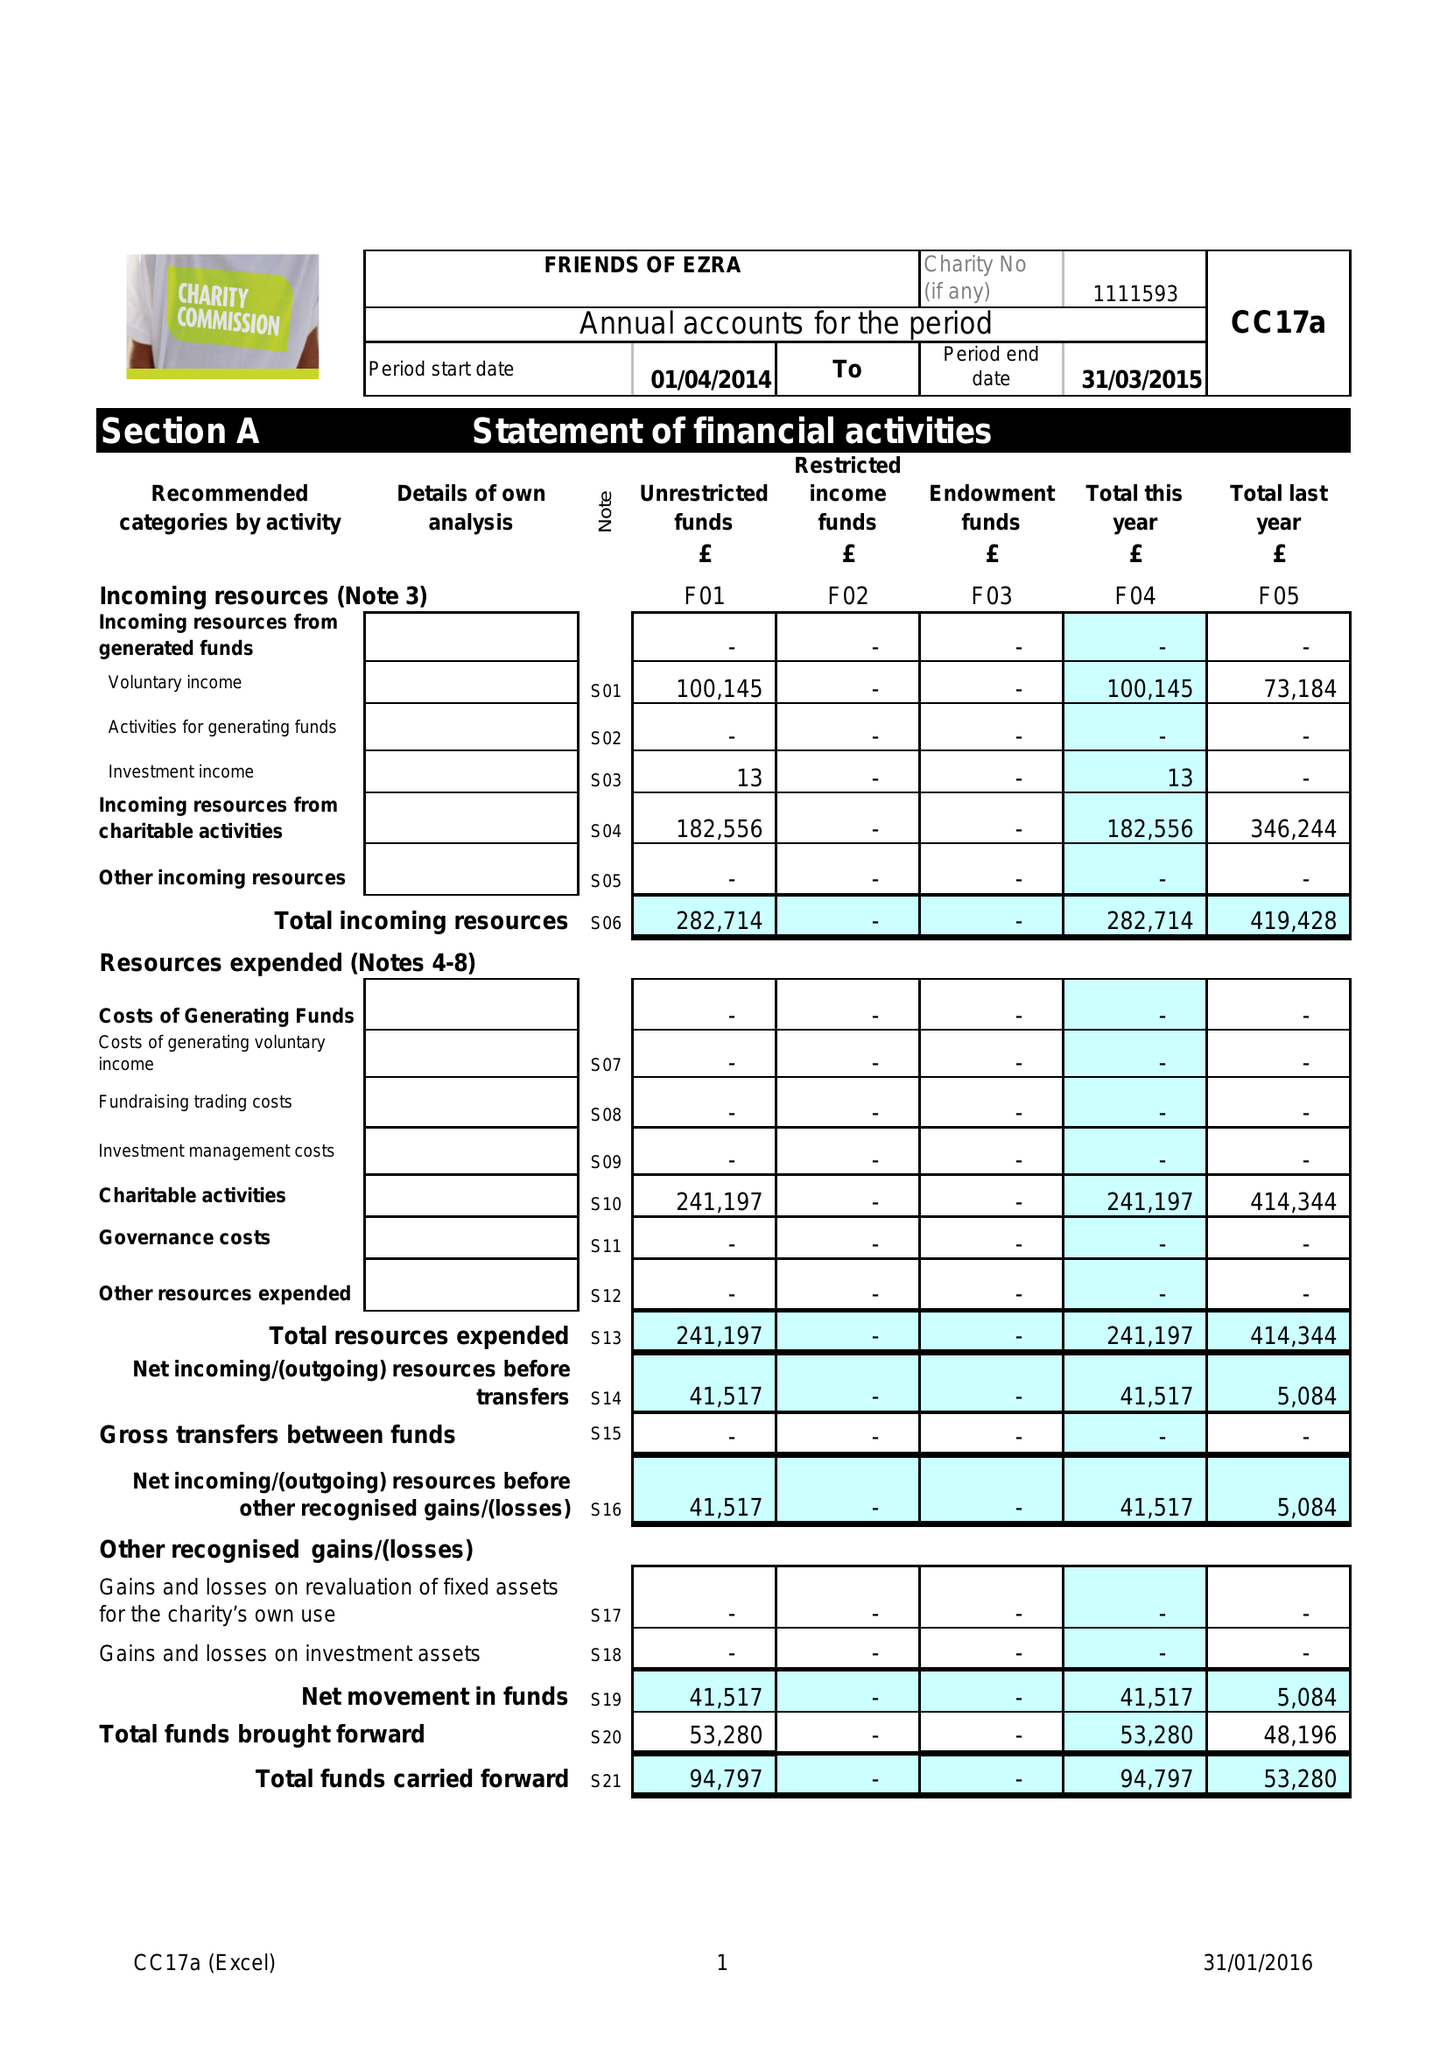What is the value for the address__postcode?
Answer the question using a single word or phrase. NW11 9BP 